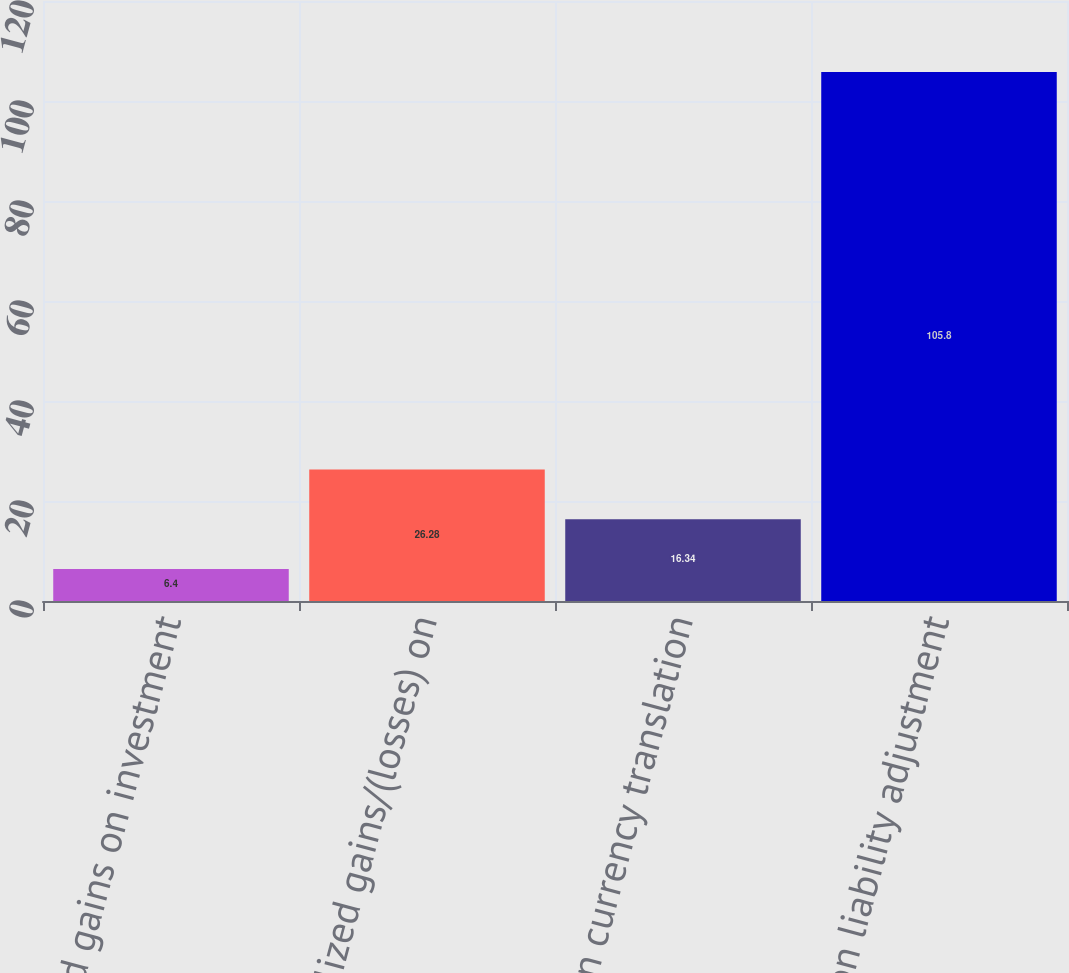<chart> <loc_0><loc_0><loc_500><loc_500><bar_chart><fcel>Unrealized gains on investment<fcel>Unrealized gains/(losses) on<fcel>Foreign currency translation<fcel>Pension liability adjustment<nl><fcel>6.4<fcel>26.28<fcel>16.34<fcel>105.8<nl></chart> 